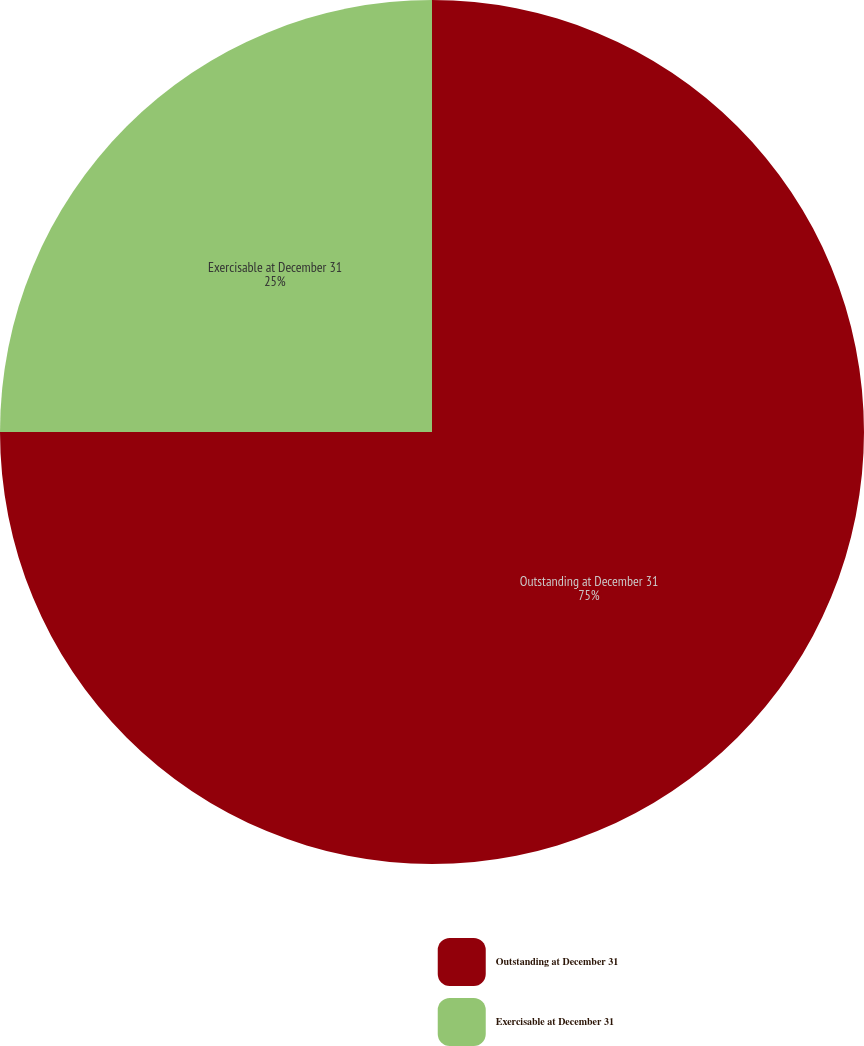Convert chart. <chart><loc_0><loc_0><loc_500><loc_500><pie_chart><fcel>Outstanding at December 31<fcel>Exercisable at December 31<nl><fcel>75.0%<fcel>25.0%<nl></chart> 